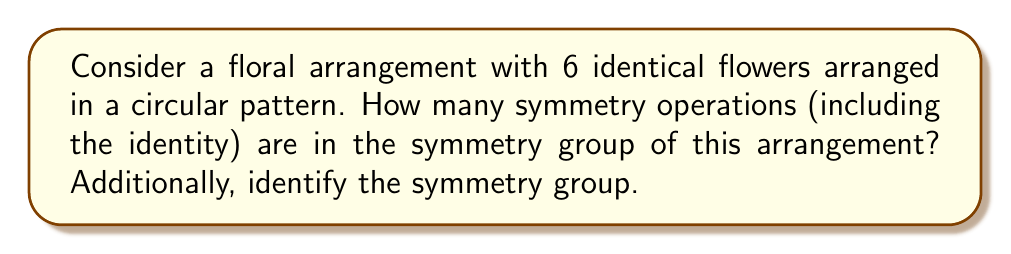What is the answer to this math problem? To analyze the symmetry group of this floral arrangement, we need to consider both rotational and reflectional symmetries:

1. Rotational symmetries:
   - The identity operation (rotation by 0°)
   - Rotation by 60°
   - Rotation by 120°
   - Rotation by 180°
   - Rotation by 240°
   - Rotation by 300°

2. Reflectional symmetries:
   There are 6 lines of reflection, each passing through the center and either a flower or the midpoint between two adjacent flowers.

To count the total number of symmetry operations:
- 6 rotations (including identity)
- 6 reflections

Total number of symmetry operations: 6 + 6 = 12

Identifying the symmetry group:
The symmetry group of this arrangement is isomorphic to $D_6$, the dihedral group of order 12. This group is generated by a rotation $r$ of order 6 and a reflection $s$, satisfying the relations:

$$r^6 = e, s^2 = e, srs = r^{-1}$$

Where $e$ is the identity element.

This group describes all the symmetries of a regular hexagon, which matches our floral arrangement's symmetry.
Answer: The symmetry group has 12 elements and is isomorphic to $D_6$, the dihedral group of order 12. 